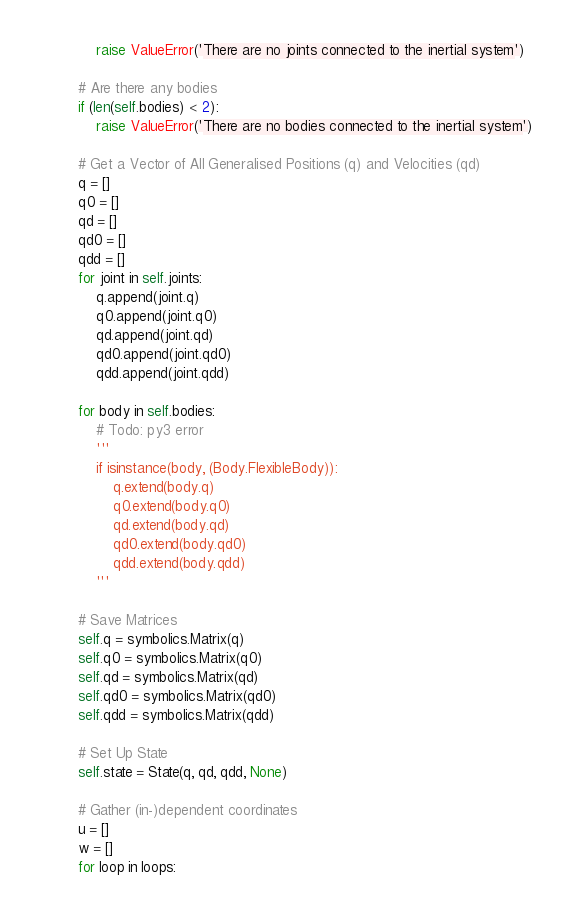Convert code to text. <code><loc_0><loc_0><loc_500><loc_500><_Python_>            raise ValueError('There are no joints connected to the inertial system')

        # Are there any bodies
        if (len(self.bodies) < 2):
            raise ValueError('There are no bodies connected to the inertial system')

        # Get a Vector of All Generalised Positions (q) and Velocities (qd)
        q = []
        q0 = []
        qd = []
        qd0 = []
        qdd = []
        for joint in self.joints:
            q.append(joint.q)
            q0.append(joint.q0)
            qd.append(joint.qd)
            qd0.append(joint.qd0)
            qdd.append(joint.qdd)

        for body in self.bodies:
            # Todo: py3 error
            '''
            if isinstance(body, (Body.FlexibleBody)):
                q.extend(body.q)
                q0.extend(body.q0)
                qd.extend(body.qd)
                qd0.extend(body.qd0)
                qdd.extend(body.qdd)
            '''

        # Save Matrices
        self.q = symbolics.Matrix(q)
        self.q0 = symbolics.Matrix(q0)
        self.qd = symbolics.Matrix(qd)
        self.qd0 = symbolics.Matrix(qd0)
        self.qdd = symbolics.Matrix(qdd)

        # Set Up State
        self.state = State(q, qd, qdd, None)

        # Gather (in-)dependent coordinates
        u = []
        w = []
        for loop in loops:</code> 